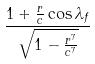Convert formula to latex. <formula><loc_0><loc_0><loc_500><loc_500>\frac { 1 + \frac { r } { c } \cos \lambda _ { f } } { \sqrt { 1 - \frac { r ^ { 7 } } { c ^ { 7 } } } }</formula> 